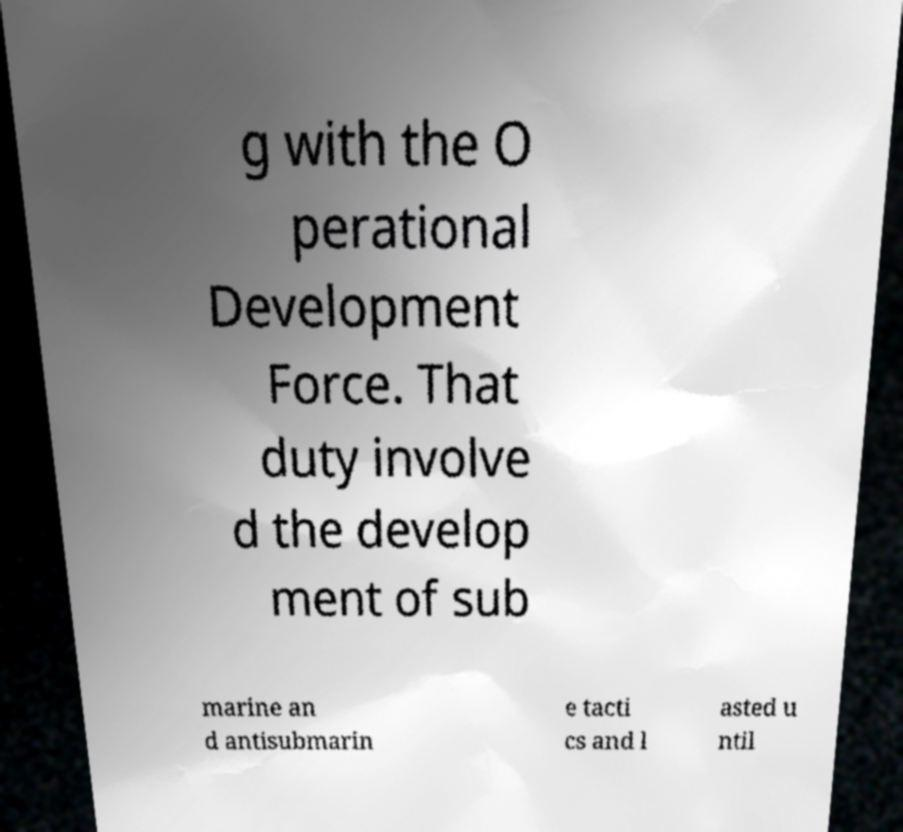Could you assist in decoding the text presented in this image and type it out clearly? g with the O perational Development Force. That duty involve d the develop ment of sub marine an d antisubmarin e tacti cs and l asted u ntil 